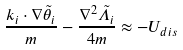Convert formula to latex. <formula><loc_0><loc_0><loc_500><loc_500>\frac { { k } _ { i } \cdot \nabla { \tilde { \theta } } _ { i } } { m } - \frac { \nabla ^ { 2 } { \tilde { \Lambda } } _ { i } } { 4 m } \approx - U _ { d i s }</formula> 